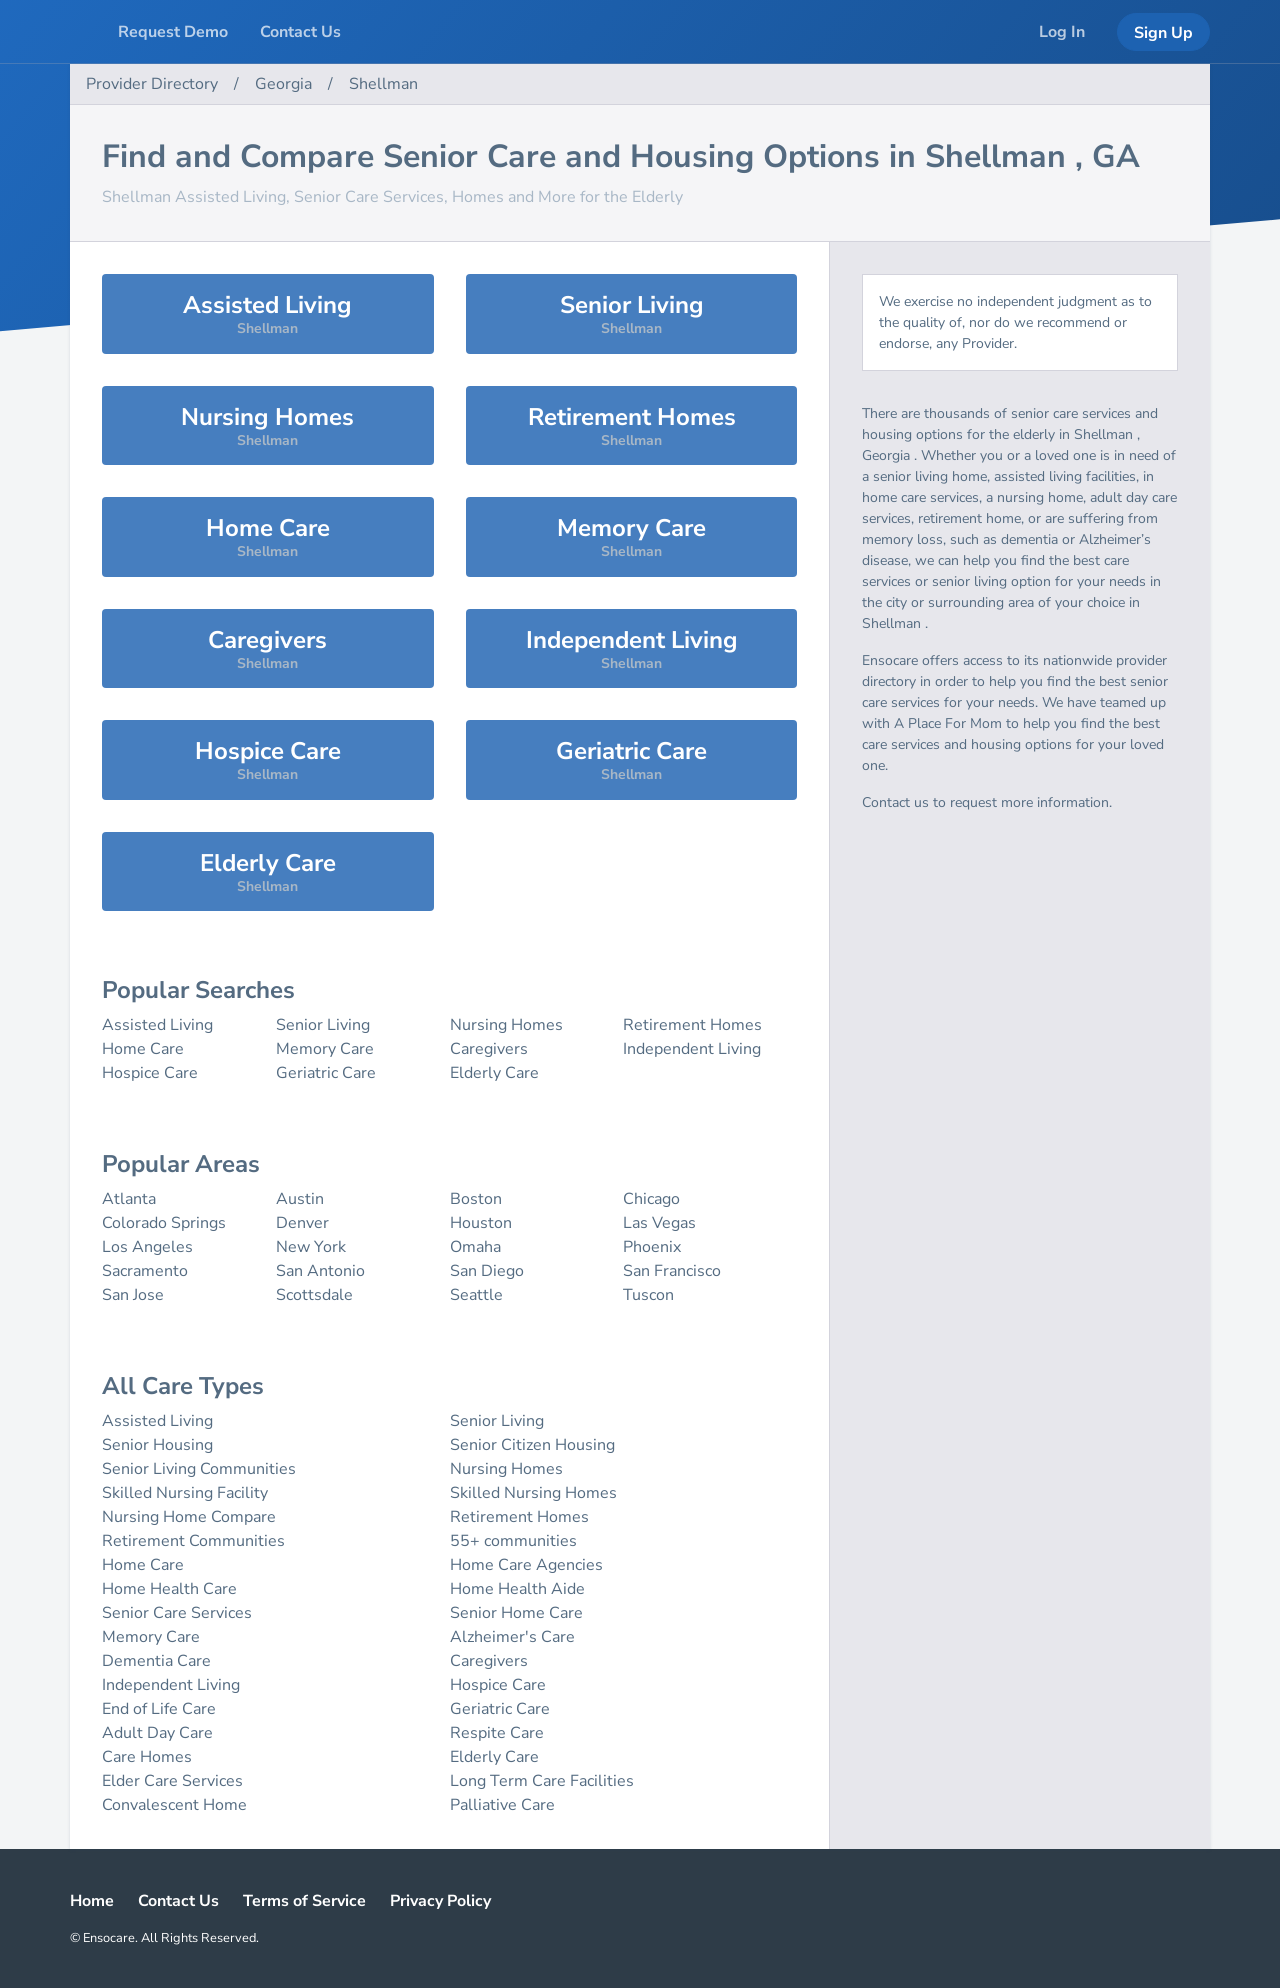What are some of the 'popular areas' mentioned for senior living, and what makes them popular? The image lists several popular areas for senior living, including Atlanta, Denver, and San Francisco, among others. These locations are popular due to their high-quality healthcare facilities, vibrant community activities, senior-friendly amenities, and in some cases, pleasant weather conditions. Many also have multiple senior living options available, from independent living to skilled nursing care, catering to diverse needs and preferences. 